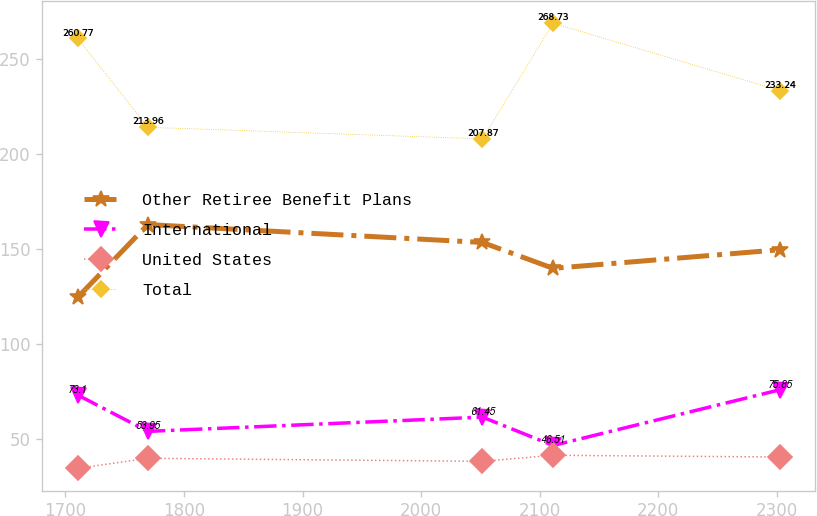Convert chart to OTSL. <chart><loc_0><loc_0><loc_500><loc_500><line_chart><ecel><fcel>Other Retiree Benefit Plans<fcel>International<fcel>United States<fcel>Total<nl><fcel>1710.21<fcel>124.44<fcel>73.1<fcel>34.49<fcel>260.77<nl><fcel>1769.48<fcel>162.76<fcel>53.95<fcel>39.77<fcel>213.96<nl><fcel>2051.8<fcel>153.36<fcel>61.45<fcel>38.18<fcel>207.87<nl><fcel>2111.42<fcel>139.73<fcel>46.51<fcel>41.36<fcel>268.73<nl><fcel>2302.87<fcel>149.53<fcel>75.85<fcel>40.46<fcel>233.24<nl></chart> 